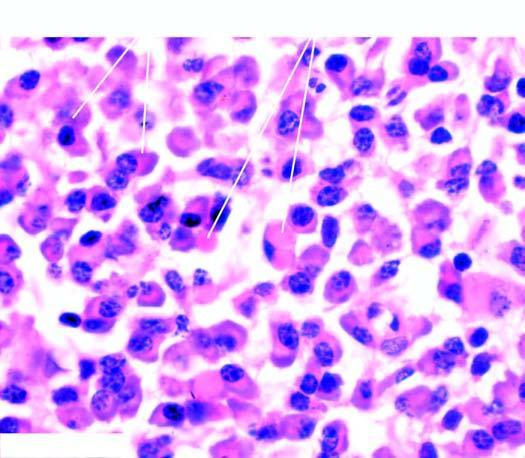does the cytoplasm show pink homogeneous globular material due to accumulated immunoglobulins?
Answer the question using a single word or phrase. Yes 